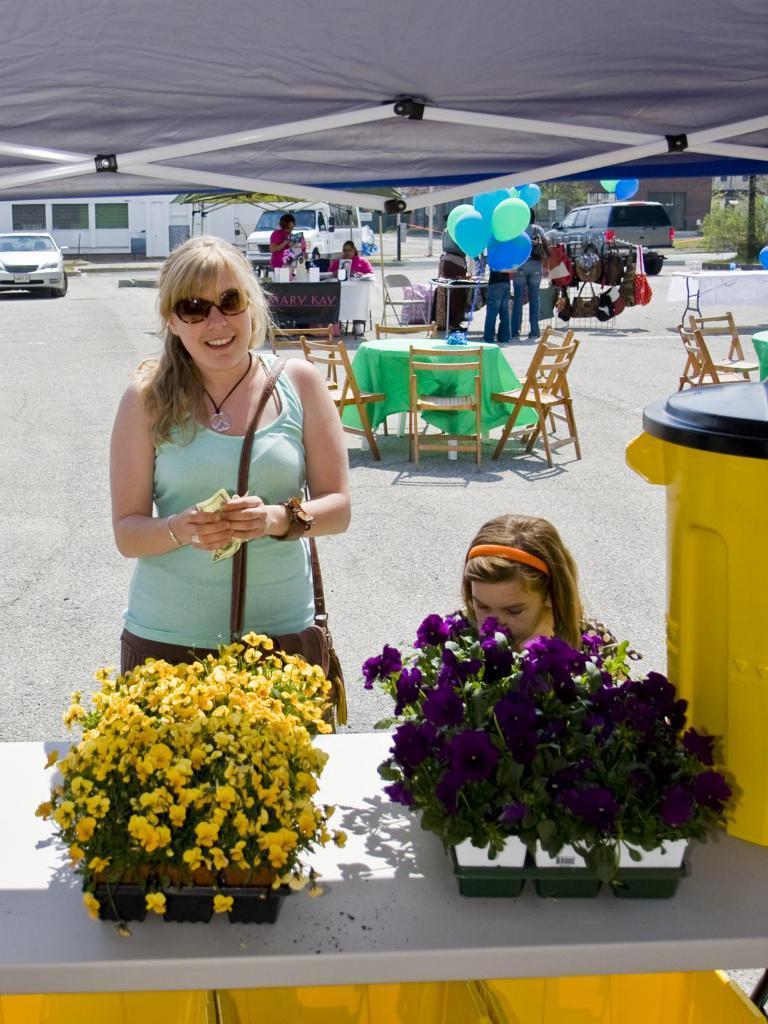Can you describe this image briefly? On the bottom of the image, on that two flower pots are placed. In front of this table there is woman standing and wearing a bag. In the background I can see few tables and chairs are arranged in an order. There are few people standing. In the background there is building and I can see two cars on the road. 